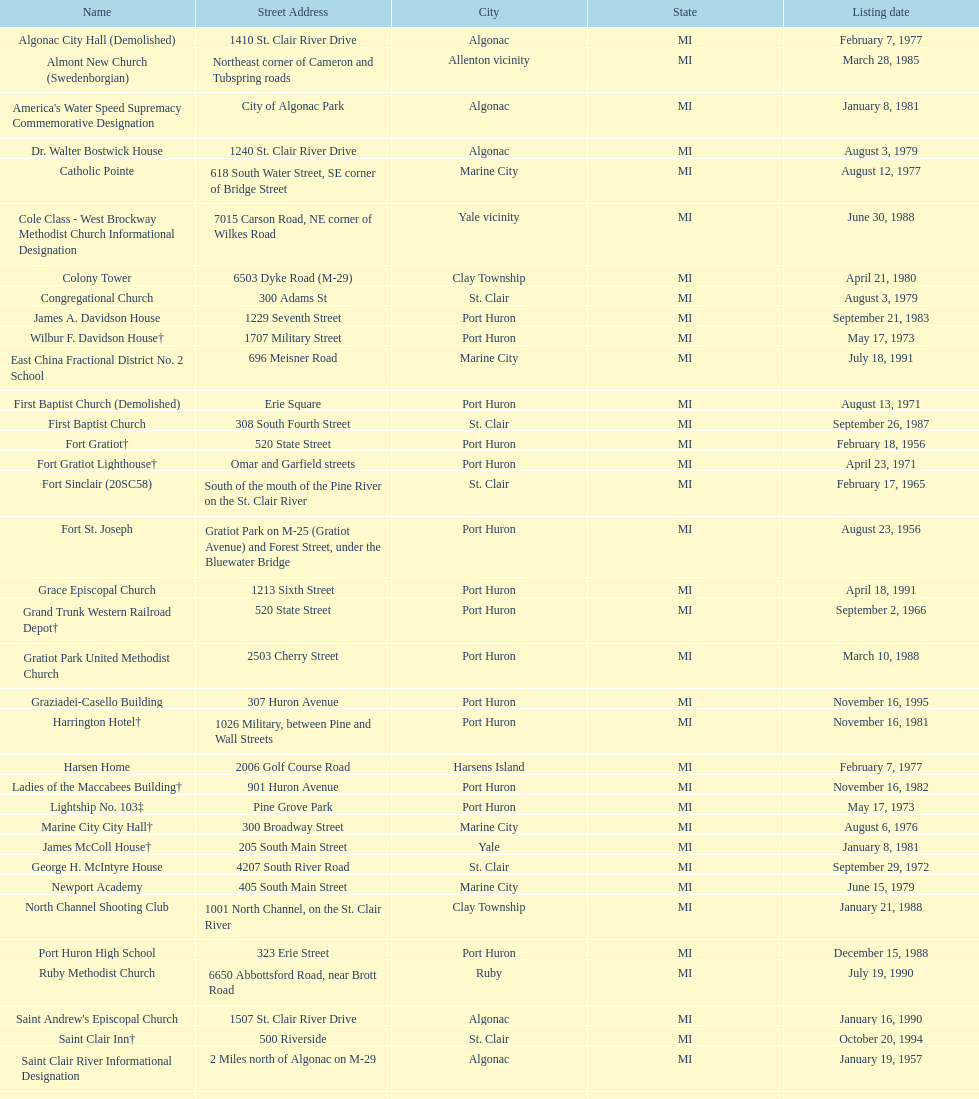Could you parse the entire table as a dict? {'header': ['Name', 'Street Address', 'City', 'State', 'Listing date'], 'rows': [['Algonac City Hall (Demolished)', '1410 St. Clair River Drive', 'Algonac', 'MI', 'February 7, 1977'], ['Almont New Church (Swedenborgian)', 'Northeast corner of Cameron and Tubspring roads', 'Allenton vicinity', 'MI', 'March 28, 1985'], ["America's Water Speed Supremacy Commemorative Designation", 'City of Algonac Park', 'Algonac', 'MI', 'January 8, 1981'], ['Dr. Walter Bostwick House', '1240 St. Clair River Drive', 'Algonac', 'MI', 'August 3, 1979'], ['Catholic Pointe', '618 South Water Street, SE corner of Bridge Street', 'Marine City', 'MI', 'August 12, 1977'], ['Cole Class - West Brockway Methodist Church Informational Designation', '7015 Carson Road, NE corner of Wilkes Road', 'Yale vicinity', 'MI', 'June 30, 1988'], ['Colony Tower', '6503 Dyke Road (M-29)', 'Clay Township', 'MI', 'April 21, 1980'], ['Congregational Church', '300 Adams St', 'St. Clair', 'MI', 'August 3, 1979'], ['James A. Davidson House', '1229 Seventh Street', 'Port Huron', 'MI', 'September 21, 1983'], ['Wilbur F. Davidson House†', '1707 Military Street', 'Port Huron', 'MI', 'May 17, 1973'], ['East China Fractional District No. 2 School', '696 Meisner Road', 'Marine City', 'MI', 'July 18, 1991'], ['First Baptist Church (Demolished)', 'Erie Square', 'Port Huron', 'MI', 'August 13, 1971'], ['First Baptist Church', '308 South Fourth Street', 'St. Clair', 'MI', 'September 26, 1987'], ['Fort Gratiot†', '520 State Street', 'Port Huron', 'MI', 'February 18, 1956'], ['Fort Gratiot Lighthouse†', 'Omar and Garfield streets', 'Port Huron', 'MI', 'April 23, 1971'], ['Fort Sinclair (20SC58)', 'South of the mouth of the Pine River on the St. Clair River', 'St. Clair', 'MI', 'February 17, 1965'], ['Fort St. Joseph', 'Gratiot Park on M-25 (Gratiot Avenue) and Forest Street, under the Bluewater Bridge', 'Port Huron', 'MI', 'August 23, 1956'], ['Grace Episcopal Church', '1213 Sixth Street', 'Port Huron', 'MI', 'April 18, 1991'], ['Grand Trunk Western Railroad Depot†', '520 State Street', 'Port Huron', 'MI', 'September 2, 1966'], ['Gratiot Park United Methodist Church', '2503 Cherry Street', 'Port Huron', 'MI', 'March 10, 1988'], ['Graziadei-Casello Building', '307 Huron Avenue', 'Port Huron', 'MI', 'November 16, 1995'], ['Harrington Hotel†', '1026 Military, between Pine and Wall Streets', 'Port Huron', 'MI', 'November 16, 1981'], ['Harsen Home', '2006 Golf Course Road', 'Harsens Island', 'MI', 'February 7, 1977'], ['Ladies of the Maccabees Building†', '901 Huron Avenue', 'Port Huron', 'MI', 'November 16, 1982'], ['Lightship No. 103‡', 'Pine Grove Park', 'Port Huron', 'MI', 'May 17, 1973'], ['Marine City City Hall†', '300 Broadway Street', 'Marine City', 'MI', 'August 6, 1976'], ['James McColl House†', '205 South Main Street', 'Yale', 'MI', 'January 8, 1981'], ['George H. McIntyre House', '4207 South River Road', 'St. Clair', 'MI', 'September 29, 1972'], ['Newport Academy', '405 South Main Street', 'Marine City', 'MI', 'June 15, 1979'], ['North Channel Shooting Club', '1001 North Channel, on the St. Clair River', 'Clay Township', 'MI', 'January 21, 1988'], ['Port Huron High School', '323 Erie Street', 'Port Huron', 'MI', 'December 15, 1988'], ['Ruby Methodist Church', '6650 Abbottsford Road, near Brott Road', 'Ruby', 'MI', 'July 19, 1990'], ["Saint Andrew's Episcopal Church", '1507 St. Clair River Drive', 'Algonac', 'MI', 'January 16, 1990'], ['Saint Clair Inn†', '500 Riverside', 'St. Clair', 'MI', 'October 20, 1994'], ['Saint Clair River Informational Designation', '2 Miles north of Algonac on M-29', 'Algonac', 'MI', 'January 19, 1957'], ['St. Clair River Tunnel‡', 'Between Johnstone & Beard, near 10th Street (portal site)', 'Port Huron', 'MI', 'August 23, 1956'], ['Saint Johannes Evangelische Kirche', '710 Pine Street, at Seventh Street', 'Port Huron', 'MI', 'March 19, 1980'], ["Saint Mary's Catholic Church and Rectory", '415 North Sixth Street, between Vine and Orchard streets', 'St. Clair', 'MI', 'September 25, 1985'], ['Jefferson Sheldon House', '807 Prospect Place', 'Port Huron', 'MI', 'April 19, 1990'], ['Trinity Evangelical Lutheran Church', '1517 Tenth Street', 'Port Huron', 'MI', 'August 29, 1996'], ['Wales Township Hall', '1372 Wales Center', 'Wales Township', 'MI', 'July 18, 1996'], ['Ward-Holland House†', '433 North Main Street', 'Marine City', 'MI', 'May 5, 1964'], ['E. C. Williams House', '2511 Tenth Avenue, between Hancock and Church streets', 'Port Huron', 'MI', 'November 18, 1993'], ['C. H. Wills & Company', 'Chrysler Plant, 840 Huron Avenue', 'Marysville', 'MI', 'June 23, 1983'], ["Woman's Benefit Association Building", '1338 Military Street', 'Port Huron', 'MI', 'December 15, 1988']]} What is the total number of locations in the city of algonac? 5. 